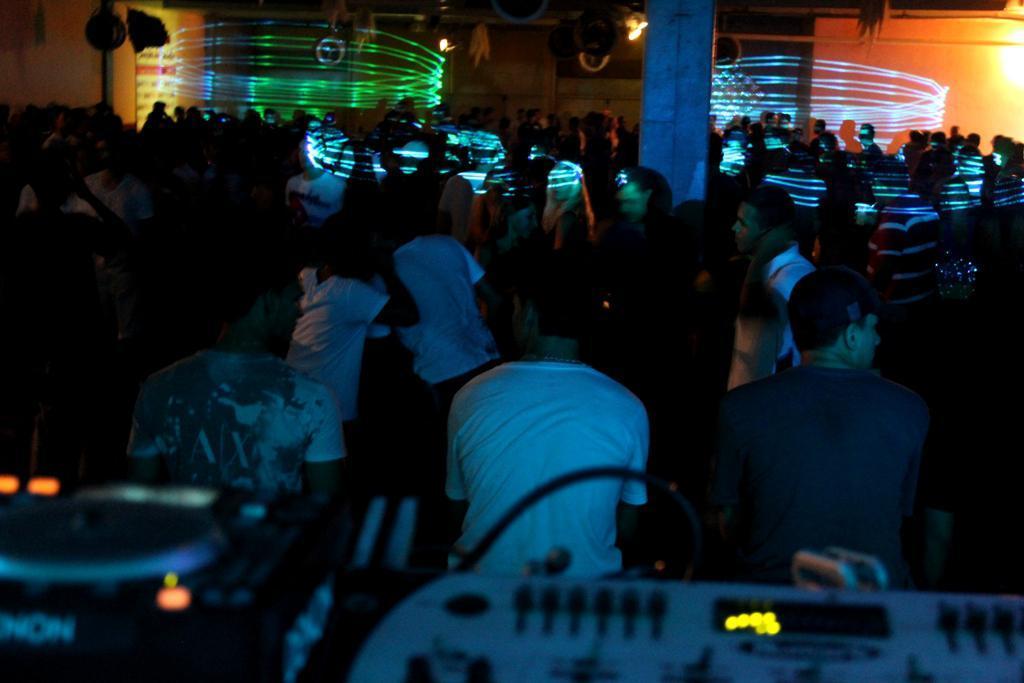Describe this image in one or two sentences. This image is taken indoors. In the background there is a wall and there are few lights. In the middle of the image there are many people. There is a pillar. At the bottom of the image there is a DJ player. 